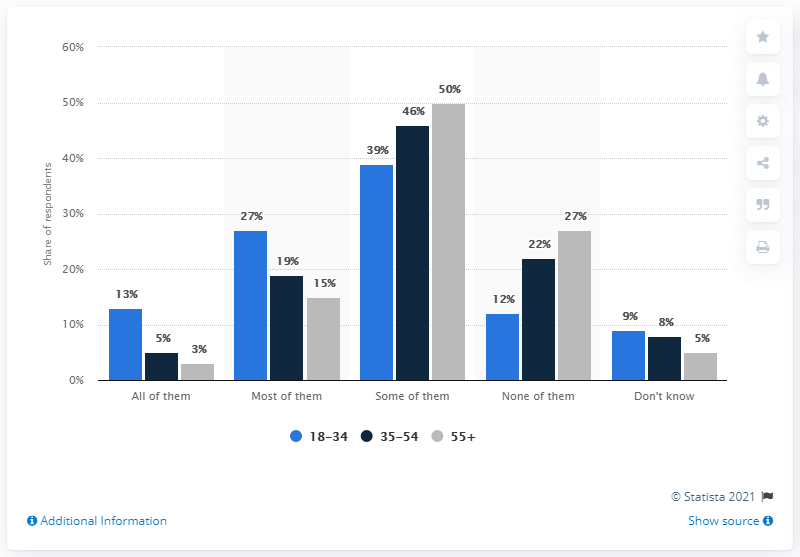Mention a couple of crucial points in this snapshot. The largest and smallest percentages from a grey bar were found, and their average was calculated by dividing the sum by 2. The result is X. The text is asking for help in determining which category a set of data falls into based on specific percentages. The text mentions that some of the data may be in more than one category, but does not provide any additional context. 